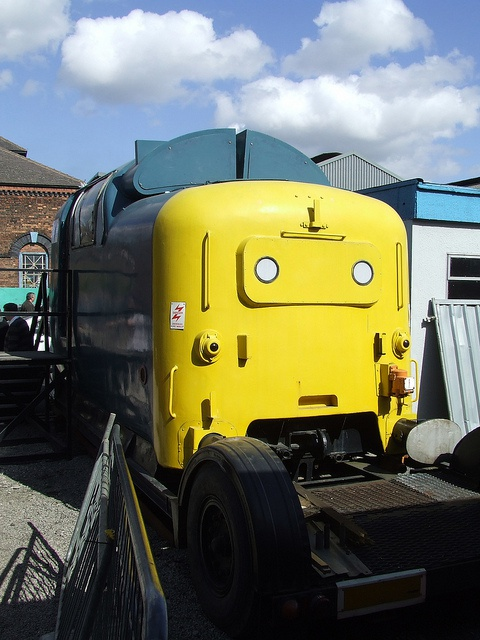Describe the objects in this image and their specific colors. I can see train in lavender, black, gold, khaki, and teal tones, people in lightgray, black, and gray tones, people in lightgray, black, gray, teal, and darkgray tones, and people in lightgray, black, gray, and teal tones in this image. 